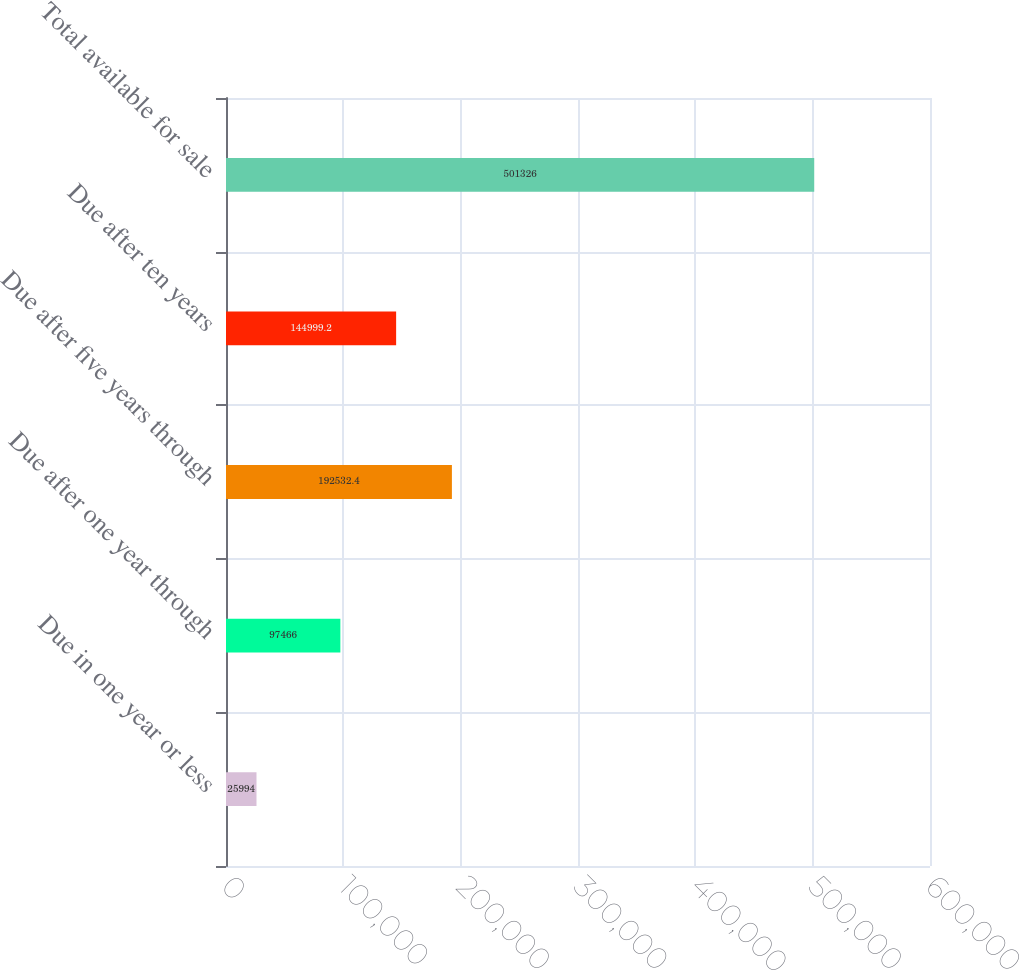Convert chart to OTSL. <chart><loc_0><loc_0><loc_500><loc_500><bar_chart><fcel>Due in one year or less<fcel>Due after one year through<fcel>Due after five years through<fcel>Due after ten years<fcel>Total available for sale<nl><fcel>25994<fcel>97466<fcel>192532<fcel>144999<fcel>501326<nl></chart> 